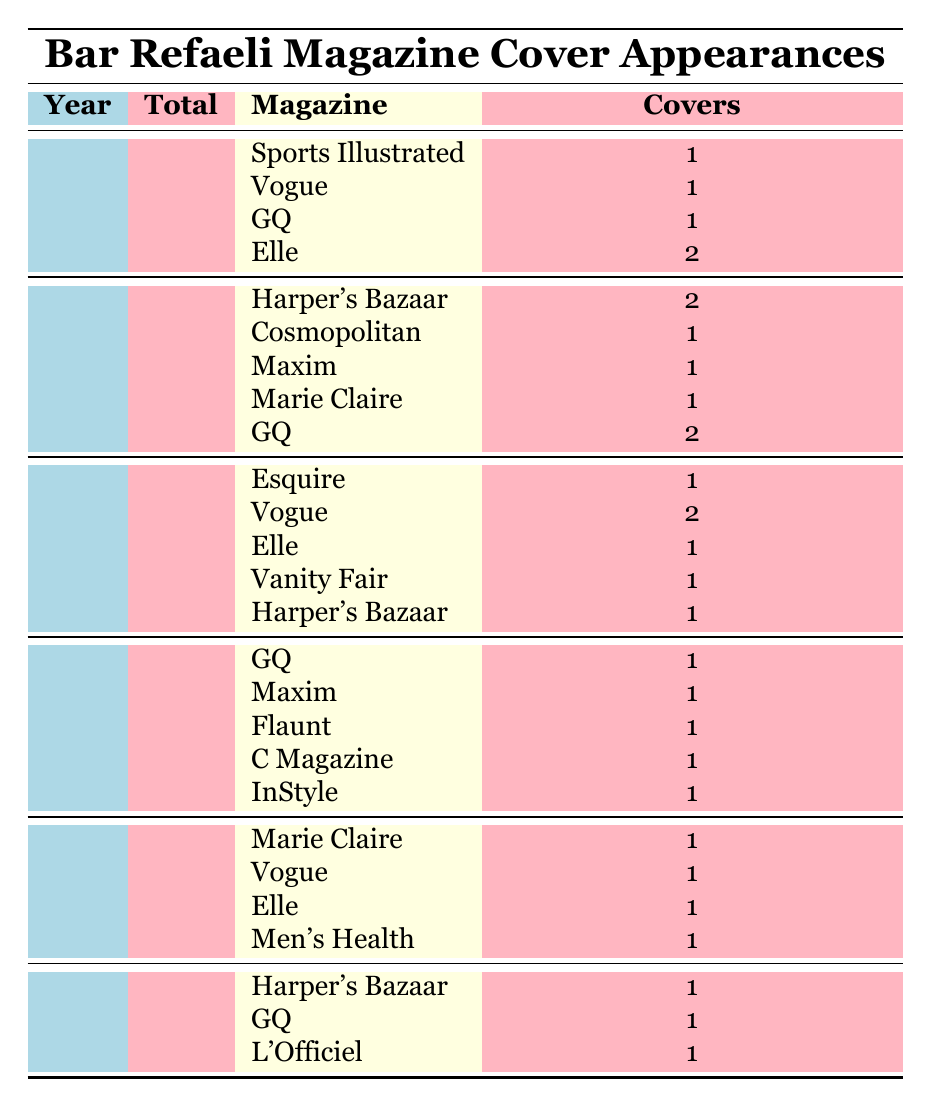What is the total number of magazine covers featuring Bar Refaeli in 2014? The table indicates that the total covers for 2014 is listed directly, which is 4.
Answer: 4 In which year did Bar Refaeli appear on the most magazine covers? Comparing the total covers across all years, 2011 has the highest total at 7 covers.
Answer: 2011 How many times did Bar Refaeli appear on the cover of Vogue between 2010 and 2015? By examining each year's data, Vogue appears 1 time in 2010, 2 times in 2012, and 1 time in 2014, totaling 4 appearances across the years.
Answer: 4 Did Bar Refaeli appear on the cover of any magazine in 2015? According to the table, Bar Refaeli did appear on covers in 2015, with a total of 3 covers listed.
Answer: Yes What was the average number of magazine covers per year from 2010 to 2015? To find the average, add all the total covers (5 + 7 + 6 + 5 + 4 + 3 = 30) and divide by the number of years (6). Thus, the average is 30 / 6 = 5.
Answer: 5 What percentage of Bar Refaeli's total magazine covers from 2010 to 2015 appeared in 2011? First, calculate the total number of covers from 2010 to 2015, which is 30. In 2011, Bar Refaeli had 7 covers. The percentage is (7 / 30) * 100 = 23.33%.
Answer: 23.33% In total, how many magazine covers featured Bar Refaeli in 2013? The table indicates that the total covers for 2013 is 5.
Answer: 5 Did Bar Refaeli make more appearances on GQ covers compared to Elle covers over the years? Summing up, Bar Refaeli appeared on GQ's cover 5 times (1 in 2010, 2 in 2011, 1 in 2013) and Elle's cover 4 times (2 in 2010, 1 in 2012, 1 in 2014), thus GQ covers are greater.
Answer: Yes 